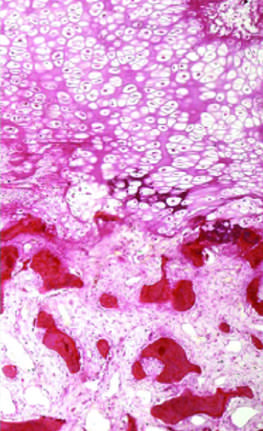what are well-formed bone?
Answer the question using a single word or phrase. Darker trabeculae 